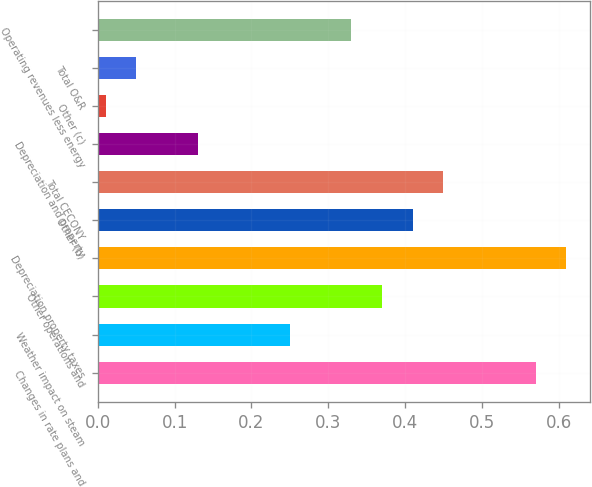Convert chart. <chart><loc_0><loc_0><loc_500><loc_500><bar_chart><fcel>Changes in rate plans and<fcel>Weather impact on steam<fcel>Other operations and<fcel>Depreciation property taxes<fcel>Other (b)<fcel>Total CECONY<fcel>Depreciation and property<fcel>Other (c)<fcel>Total O&R<fcel>Operating revenues less energy<nl><fcel>0.57<fcel>0.25<fcel>0.37<fcel>0.61<fcel>0.41<fcel>0.45<fcel>0.13<fcel>0.01<fcel>0.05<fcel>0.33<nl></chart> 